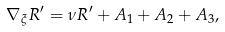<formula> <loc_0><loc_0><loc_500><loc_500>\nabla _ { \xi } R ^ { \prime } = \nu R ^ { \prime } + A _ { 1 } + A _ { 2 } + A _ { 3 } ,</formula> 